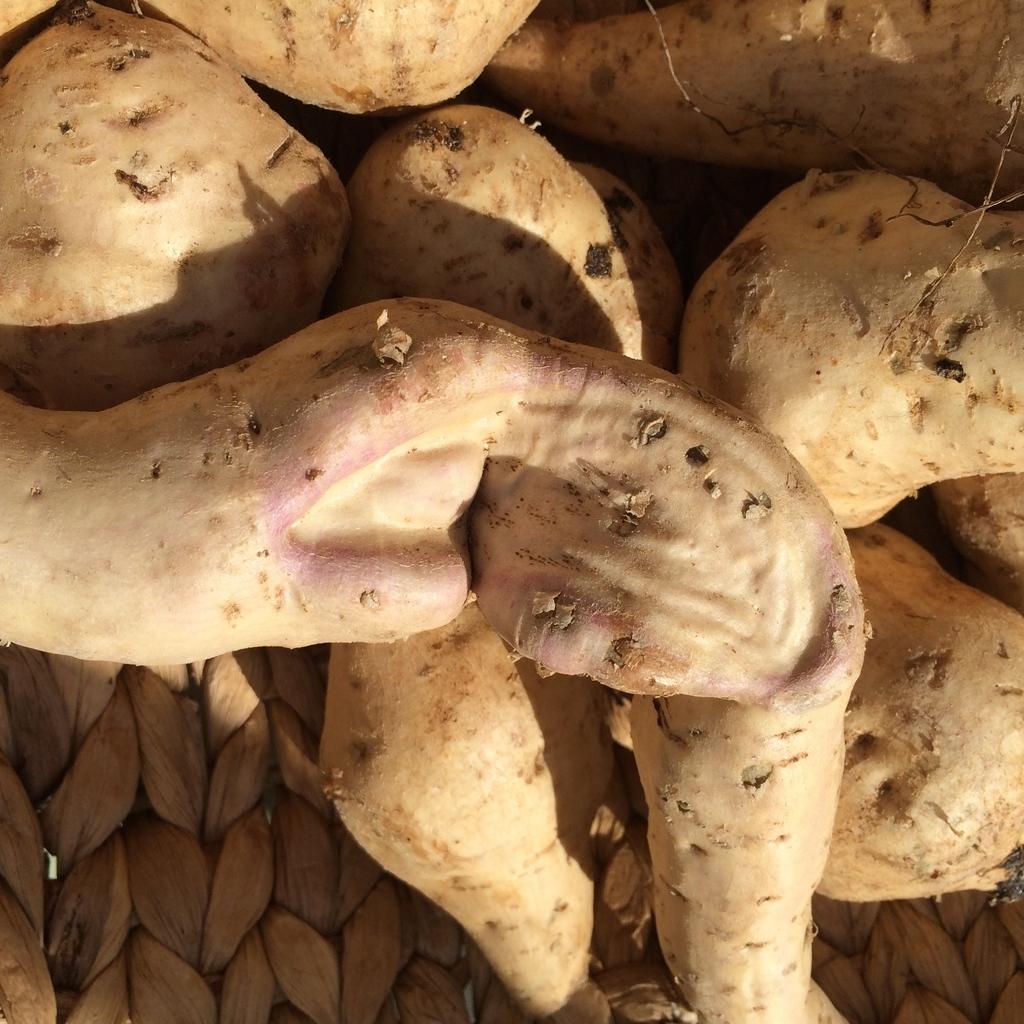How would you summarize this image in a sentence or two? In this picture we can see there are sweet potato on an object. 